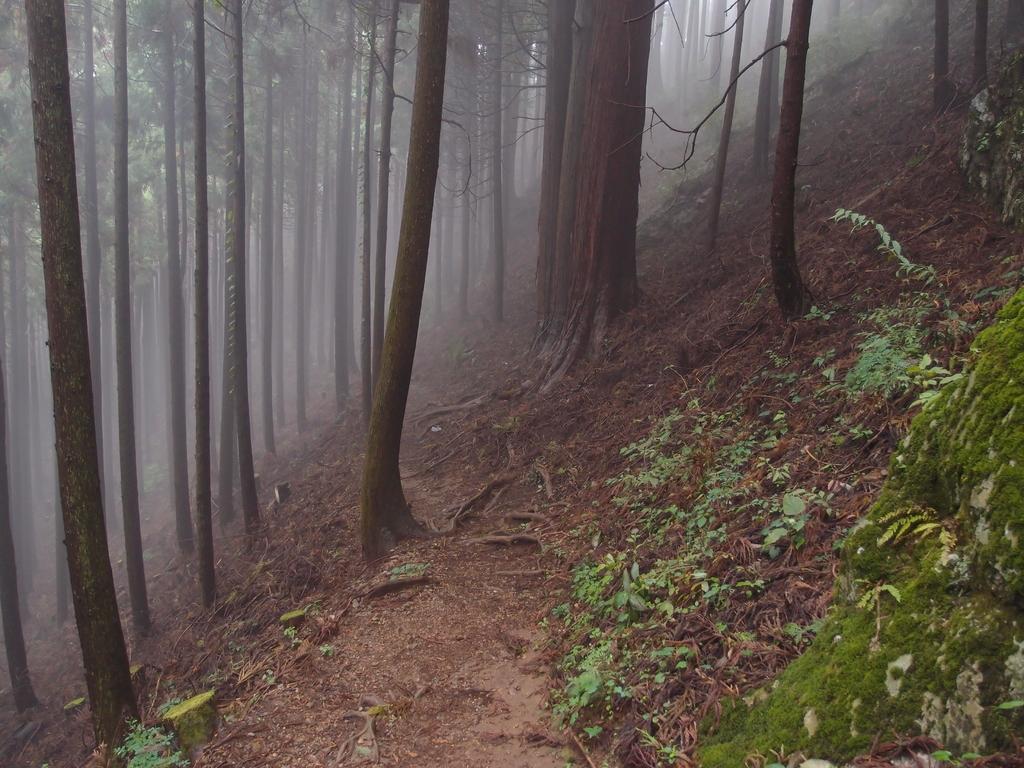Please provide a concise description of this image. In this picture we can see plants, trees on the path and a fog. 